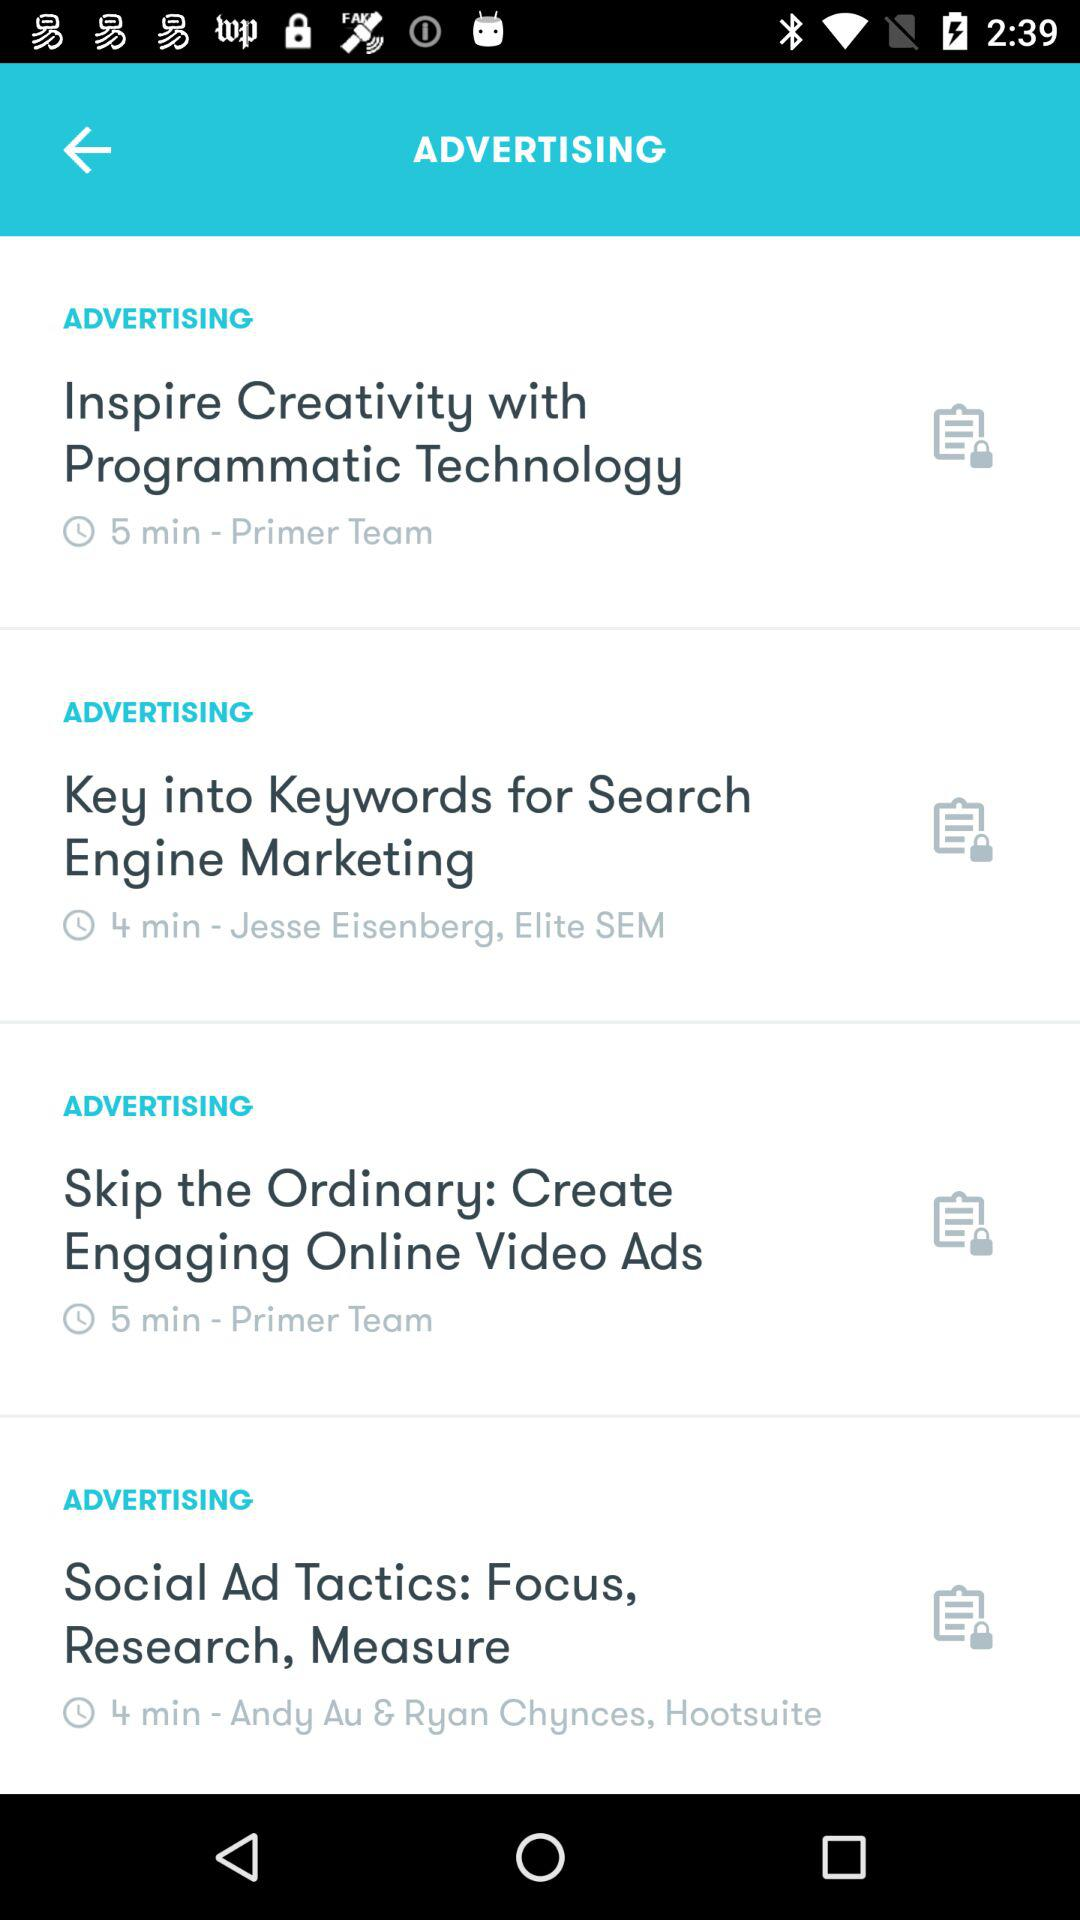How many videos are longer than 4 minutes?
Answer the question using a single word or phrase. 2 